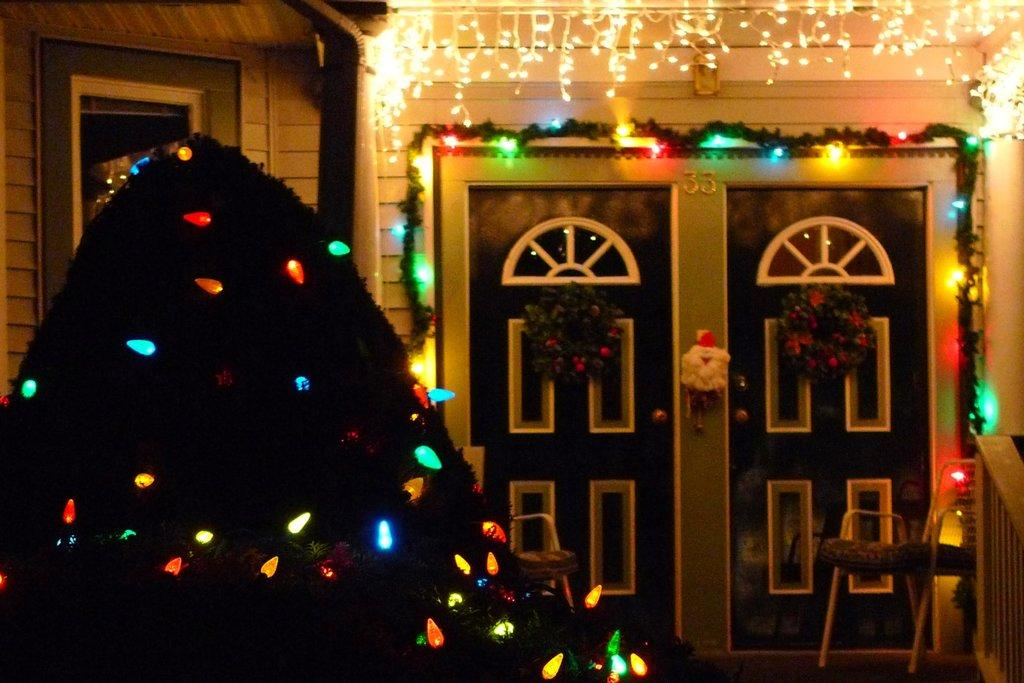What can be seen on the doors in the image? There are wreaths on the doors in the image. What type of decorations are present on the walls in the image? There are decorative lights on the walls in the image. How many spiders are crawling on the wreaths in the image? There are no spiders present in the image; it only features wreaths on the doors and decorative lights on the walls. Where is the playground located in the image? There is no playground present in the image. 